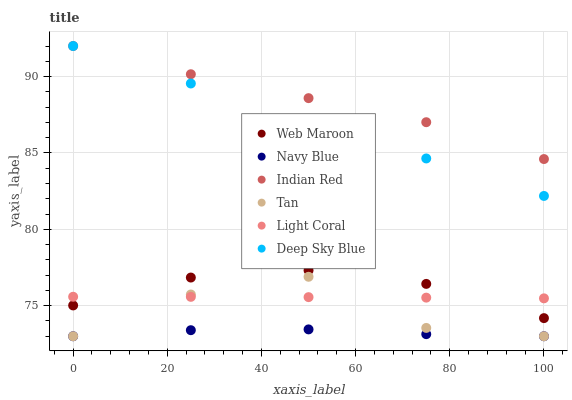Does Navy Blue have the minimum area under the curve?
Answer yes or no. Yes. Does Indian Red have the maximum area under the curve?
Answer yes or no. Yes. Does Web Maroon have the minimum area under the curve?
Answer yes or no. No. Does Web Maroon have the maximum area under the curve?
Answer yes or no. No. Is Deep Sky Blue the smoothest?
Answer yes or no. Yes. Is Tan the roughest?
Answer yes or no. Yes. Is Navy Blue the smoothest?
Answer yes or no. No. Is Navy Blue the roughest?
Answer yes or no. No. Does Navy Blue have the lowest value?
Answer yes or no. Yes. Does Web Maroon have the lowest value?
Answer yes or no. No. Does Deep Sky Blue have the highest value?
Answer yes or no. Yes. Does Web Maroon have the highest value?
Answer yes or no. No. Is Light Coral less than Deep Sky Blue?
Answer yes or no. Yes. Is Deep Sky Blue greater than Tan?
Answer yes or no. Yes. Does Indian Red intersect Deep Sky Blue?
Answer yes or no. Yes. Is Indian Red less than Deep Sky Blue?
Answer yes or no. No. Is Indian Red greater than Deep Sky Blue?
Answer yes or no. No. Does Light Coral intersect Deep Sky Blue?
Answer yes or no. No. 